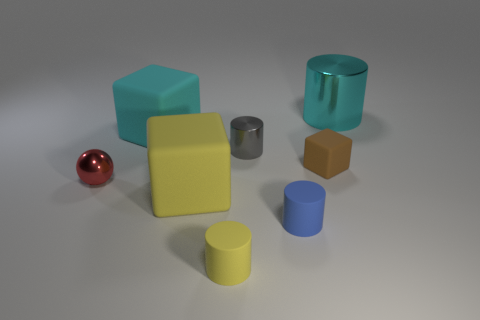What is the size of the blue object that is the same material as the cyan block?
Your response must be concise. Small. Do the tiny metal thing that is on the right side of the tiny shiny ball and the big object in front of the red metal sphere have the same shape?
Ensure brevity in your answer.  No. What is the color of the tiny object that is made of the same material as the tiny red sphere?
Your answer should be very brief. Gray. Do the cube that is in front of the red thing and the yellow rubber cylinder in front of the small brown thing have the same size?
Provide a short and direct response. No. What is the shape of the metallic thing that is behind the tiny brown cube and to the left of the large metallic object?
Your response must be concise. Cylinder. Is there a large yellow ball made of the same material as the large yellow cube?
Your response must be concise. No. There is a big object that is the same color as the big metallic cylinder; what is it made of?
Offer a very short reply. Rubber. Do the big cyan object to the left of the yellow block and the tiny thing on the left side of the tiny yellow rubber object have the same material?
Your response must be concise. No. Is the number of tiny yellow rubber objects greater than the number of small matte things?
Ensure brevity in your answer.  No. There is a shiny cylinder that is in front of the large cyan thing to the right of the yellow thing that is behind the small yellow rubber cylinder; what color is it?
Give a very brief answer. Gray. 